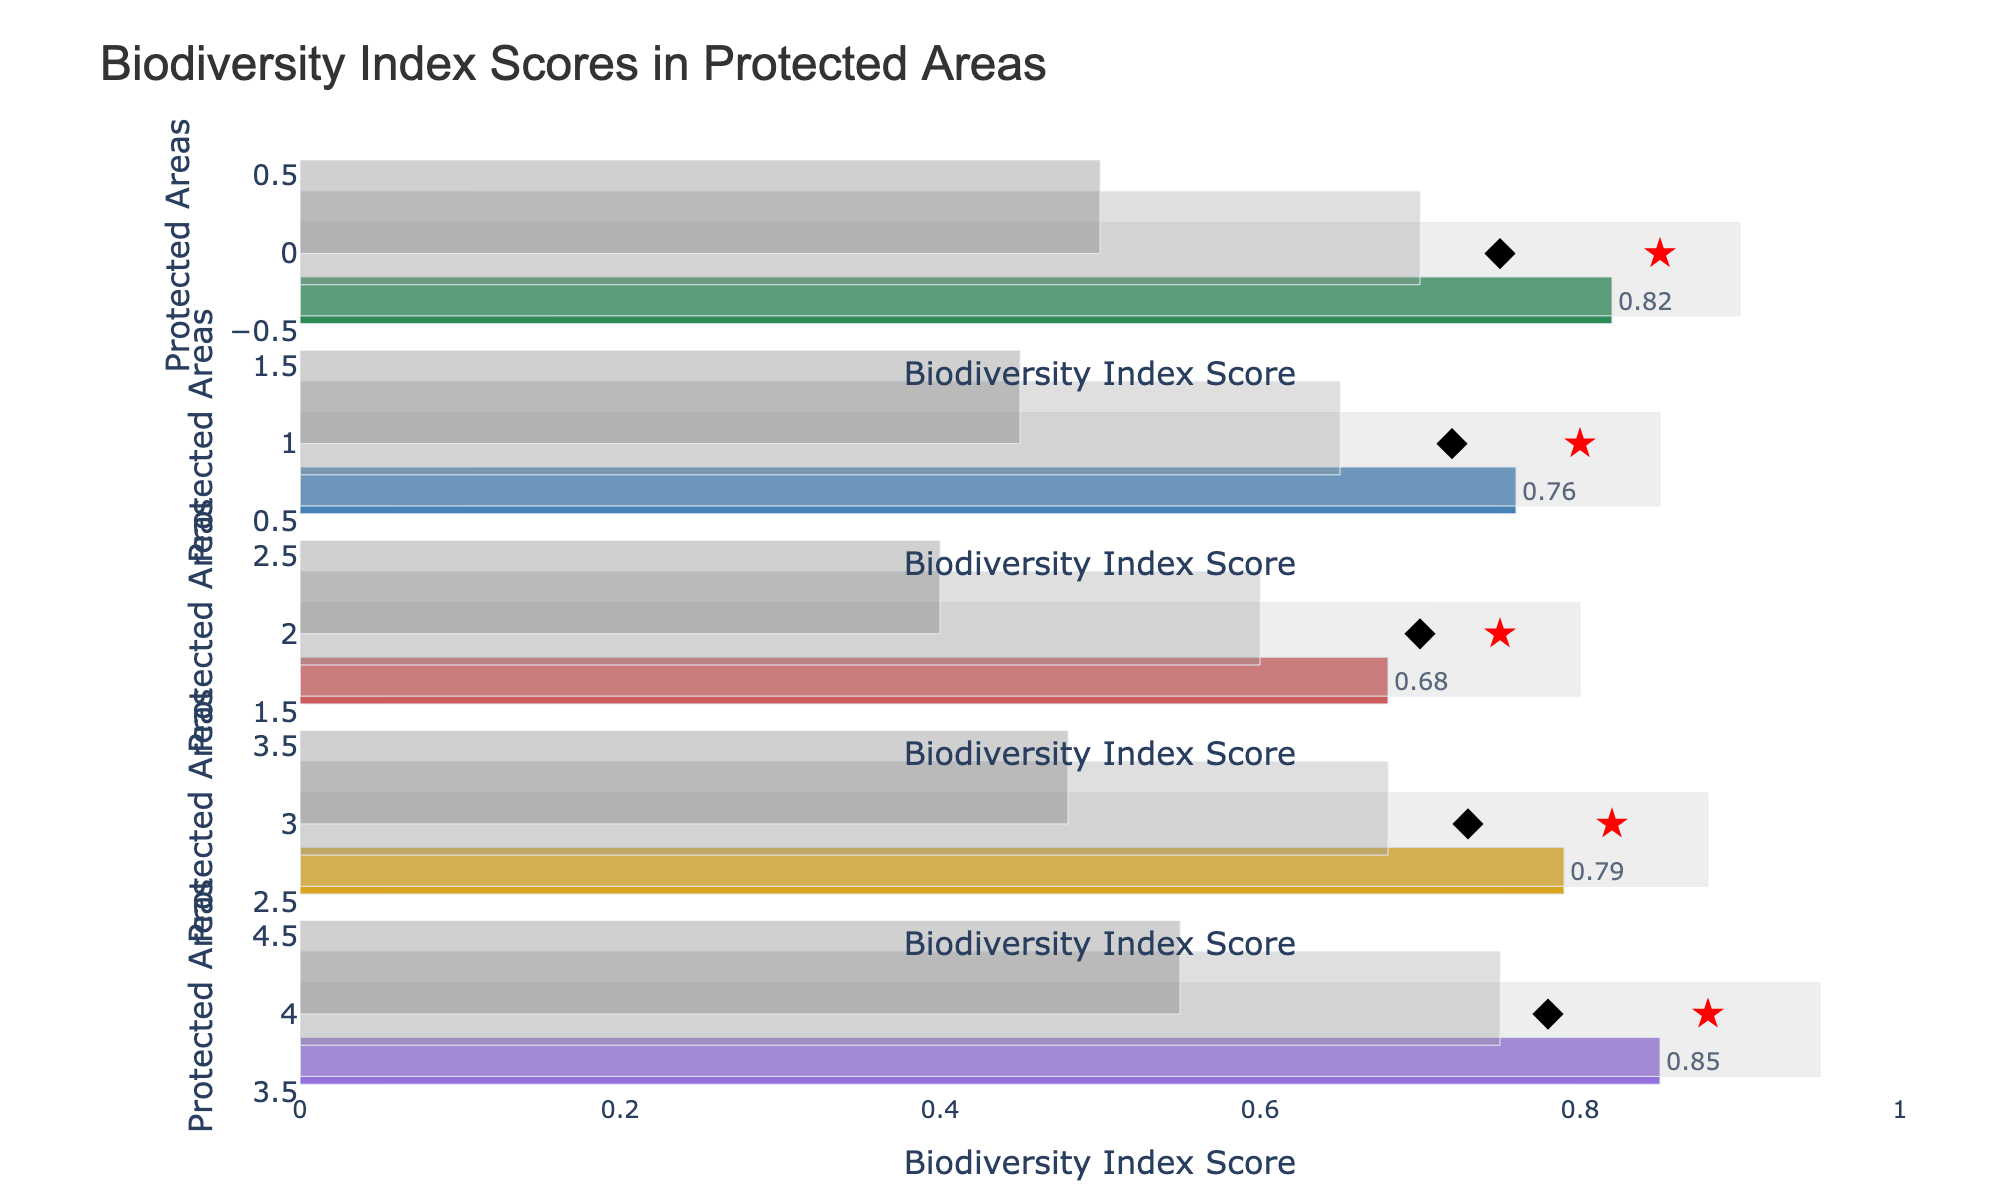What's the title of the chart? The title is generally located at the top of the chart in a larger and bolder font. We can see an overarching text that reads "Biodiversity Index Scores in Protected Areas," indicating the focus of the plot.
Answer: Biodiversity Index Scores in Protected Areas What is the biodiversity index score for the Amazon Rainforest compared to its target? The Amazon Rainforest has an 'Actual' score bar showing 0.82, and a star marker indicating the 'Target' at 0.85. These score markers provide a straightforward comparison.
Answer: 0.82 vs 0.85 Which protected area has the highest comparative biodiversity index score and what is it? Each subplot has a diamond marker representing the 'Comparative' score. Observing these, we find that the Galapagos Islands have the highest comparative score at 0.78.
Answer: Galapagos Islands, 0.78 How many protected areas have actual biodiversity index scores falling within the range of 0.75 to 0.85? Observing the 'Actual' bars and their respective values, the Amazon Rainforest (0.82) and Yellowstone National Park (0.76) fall within the 0.75 to 0.85 range, totaling to 2 protected areas.
Answer: 2 Are there any protected areas where the actual biodiversity index score meets or exceeds the target? We compare the 'Actual' bars directly against the 'Target' star markers. None of the visible 'Actual' scores equal or exceed their respective 'Target' scores.
Answer: No Which protected area has a target biodiversity index score of 0.88? The ‘Target’ star marker on the Galapagos Islands subplot shows a score of 0.88.
Answer: Galapagos Islands Which protected area has the largest gap between its actual and comparative biodiversity index scores? We note the differences by visual comparison. The Great Barrier Reef shows an actual score of 0.68 and a comparative score of 0.7, making it the smallest gap. However, the largest gap can be noticed when comparing other markers.
Answer: Serengeti National Park, 0.79 vs. 0.73, gap = 0.06 What are the range boundaries for the Great Barrier Reef? Observing the stacked bar sections, the darkest segment ends at 0.4, the middle one at 0.6, and the lightest one at 0.8, indicating the range boundaries.
Answer: 0.4, 0.6, 0.8 How do the comparative and target biodiversity index scores for Serengeti National Park compare? On the Serengeti National Park subplot, the diamond marker for ‘Comparative' shows 0.73 and the star marker for ‘Target’ indicates 0.82, giving both scores for direct comparison.
Answer: 0.73 vs 0.82 Which protected area is the closest to reaching its target biodiversity index score? By visually comparing the actual and target values, the Amazon Rainforest (0.82 to 0.85) has the smallest gap, making it the closest to its target.
Answer: Amazon Rainforest 